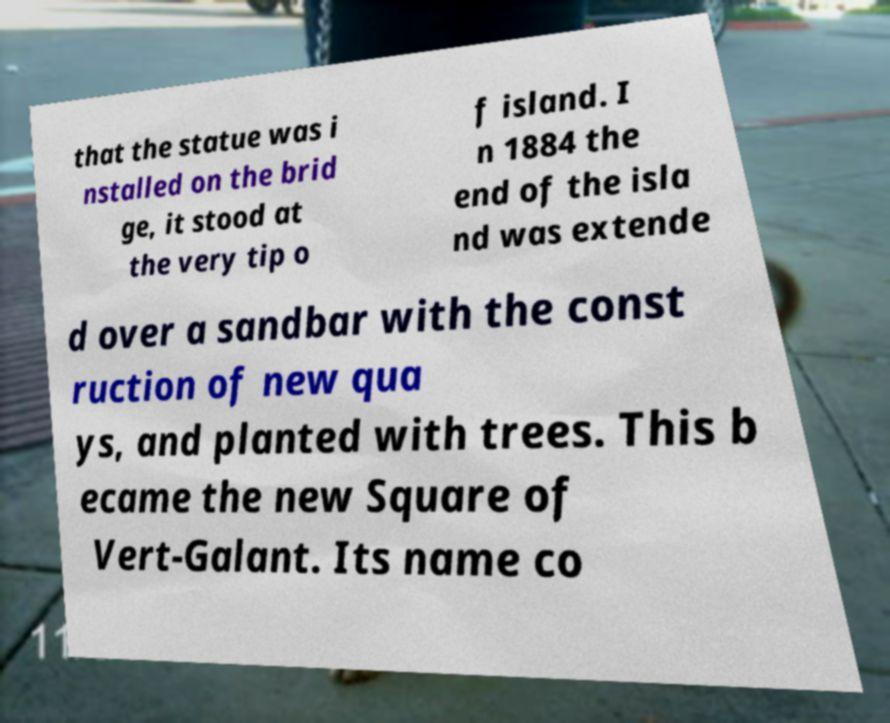There's text embedded in this image that I need extracted. Can you transcribe it verbatim? that the statue was i nstalled on the brid ge, it stood at the very tip o f island. I n 1884 the end of the isla nd was extende d over a sandbar with the const ruction of new qua ys, and planted with trees. This b ecame the new Square of Vert-Galant. Its name co 